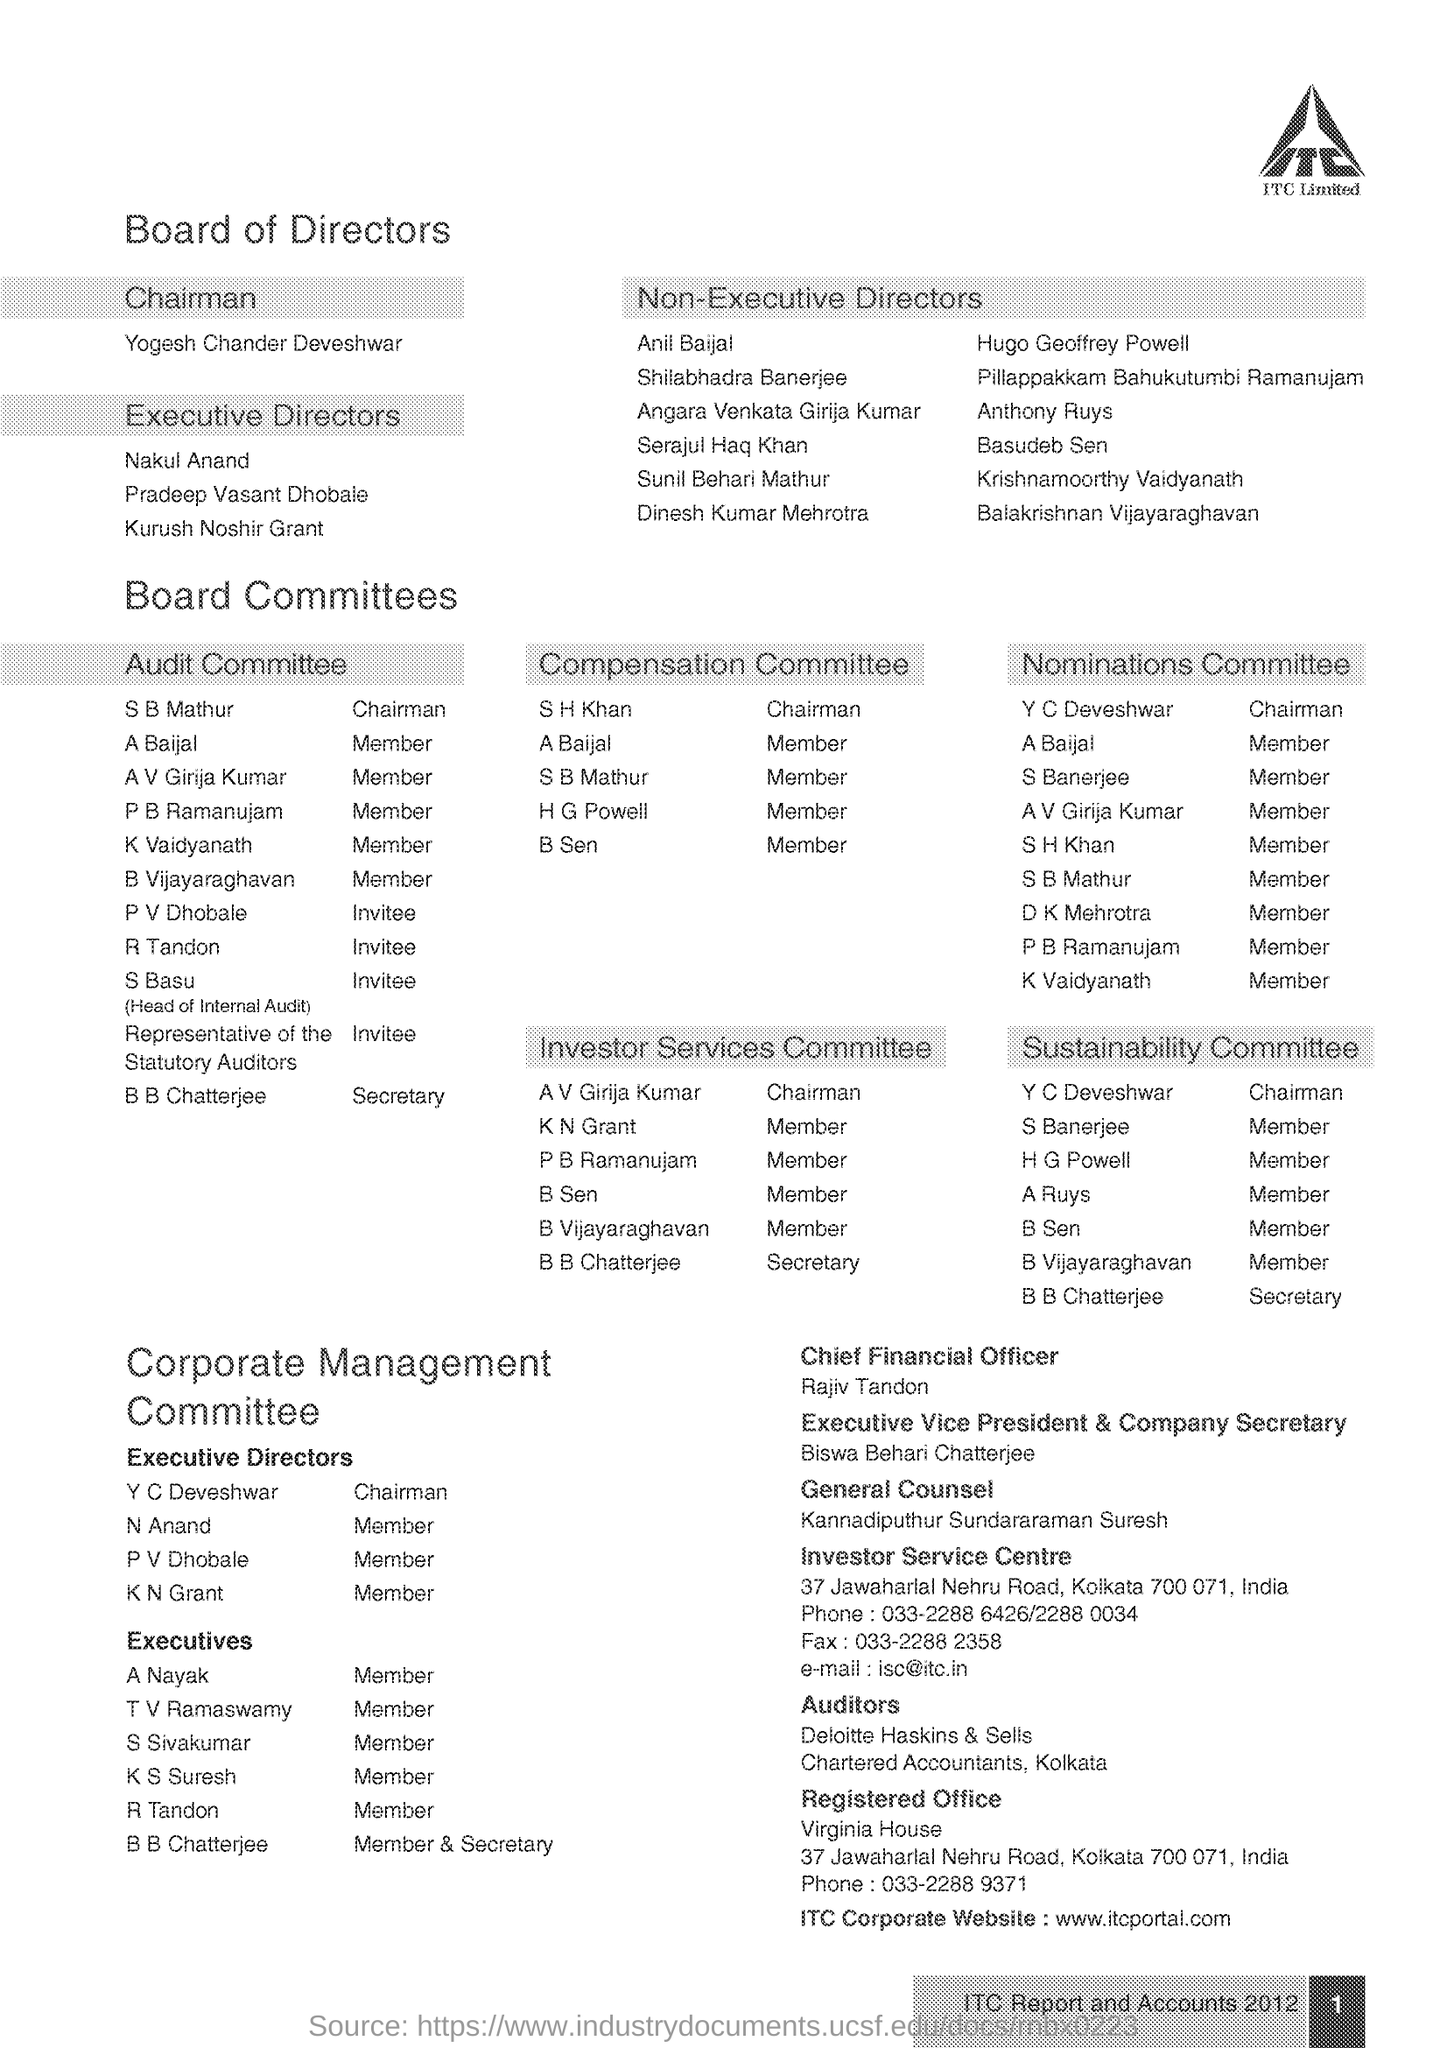Outline some significant characteristics in this image. According to the document, Kannadiputhur Sundararaman Suresh is the General Counsel. The Chairman of the Board of Directors is Yogesh Chander Deveshwar. Biswa Behari Chatterjee is the Executive Vice President and Company Secretary of a company. ITC Limited is led by Rajiv Tandon, who serves as the Chief Financial Officer of the company. The Chairman of the Audit Committee is S.B. Mathur. 